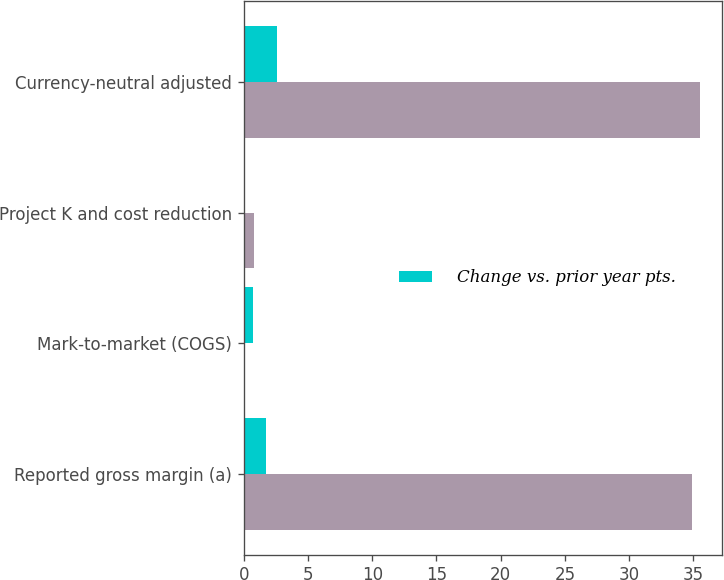<chart> <loc_0><loc_0><loc_500><loc_500><stacked_bar_chart><ecel><fcel>Reported gross margin (a)<fcel>Mark-to-market (COGS)<fcel>Project K and cost reduction<fcel>Currency-neutral adjusted<nl><fcel>nan<fcel>34.9<fcel>0.1<fcel>0.8<fcel>35.5<nl><fcel>Change vs. prior year pts.<fcel>1.7<fcel>0.7<fcel>0.1<fcel>2.6<nl></chart> 